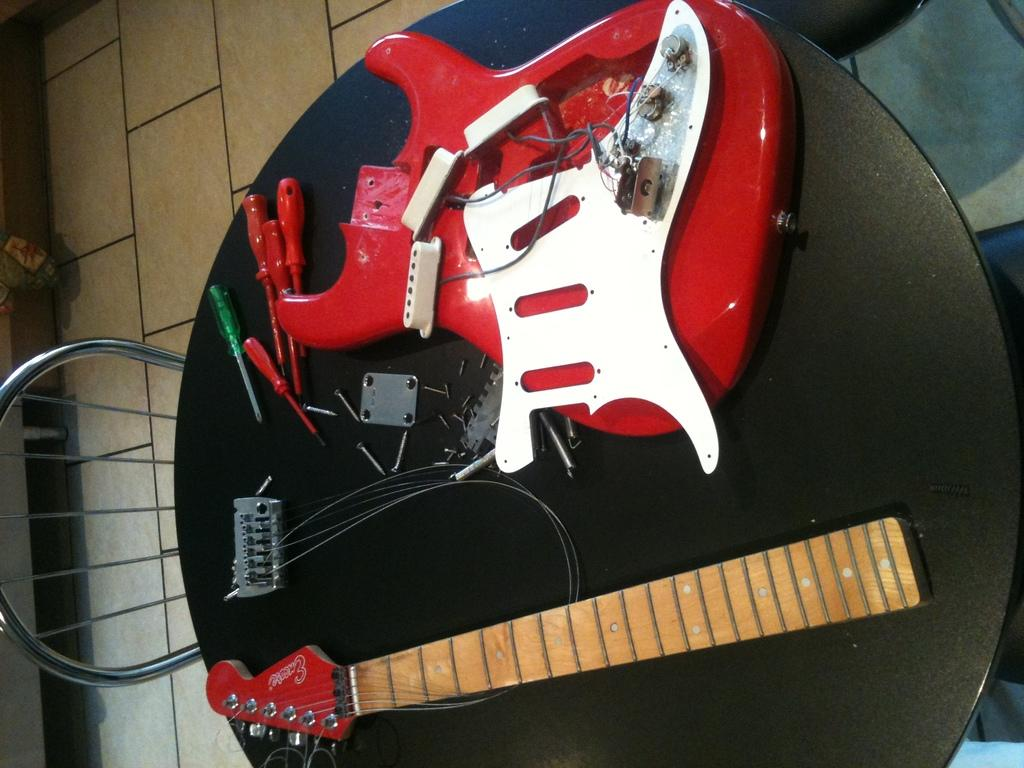What type of furniture is present in the image? There is a table and a chair in the image. What is placed on the table in the image? There are parts of a guitar on the table in the image. What tools are visible in the image? There are screwdrivers in the image. What small metal objects are present in the image? There are screws in the image. What type of fowl can be seen arguing with a fan in the image? There is no fowl or fan present in the image. What type of fan is used to cool down the guitar parts in the image? There is no fan present in the image; the guitar parts are on a table. 